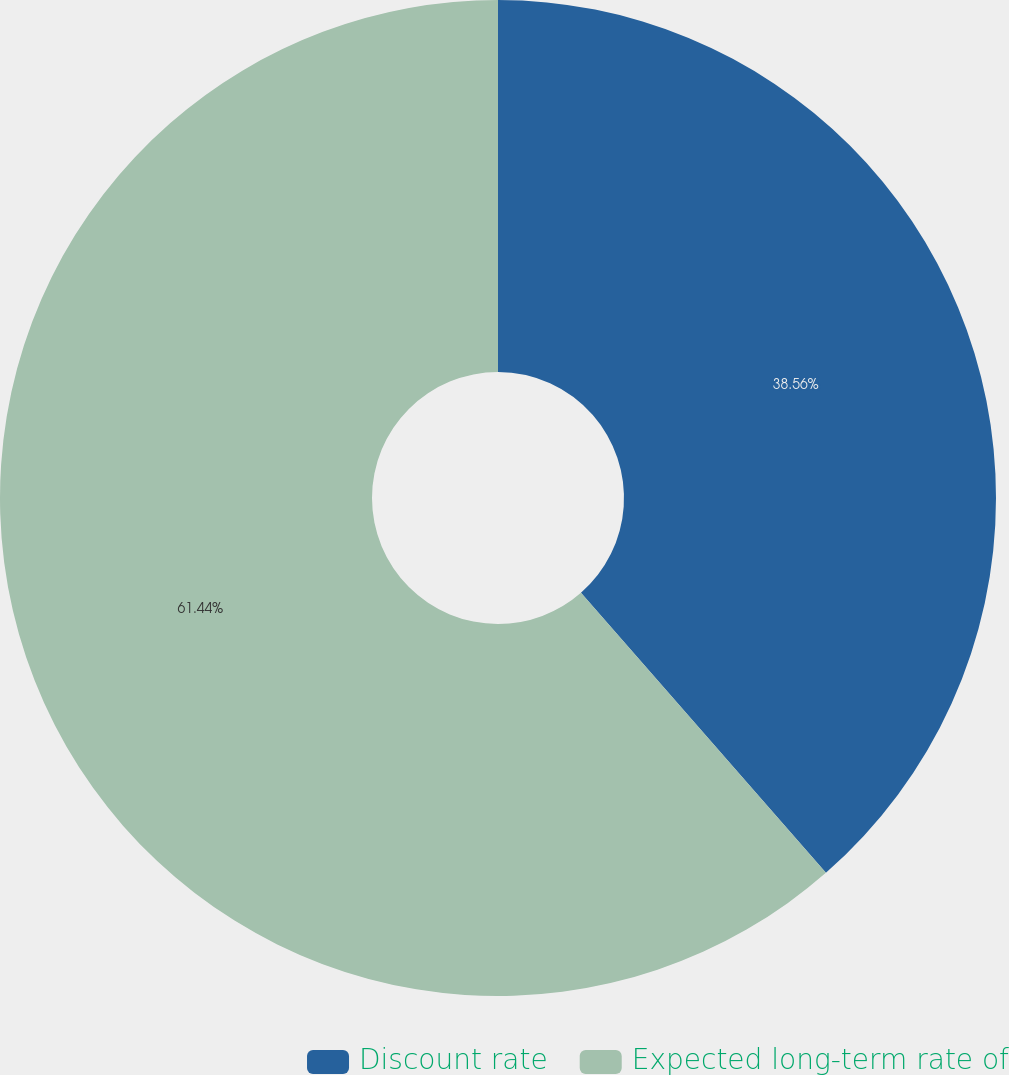<chart> <loc_0><loc_0><loc_500><loc_500><pie_chart><fcel>Discount rate<fcel>Expected long-term rate of<nl><fcel>38.56%<fcel>61.44%<nl></chart> 